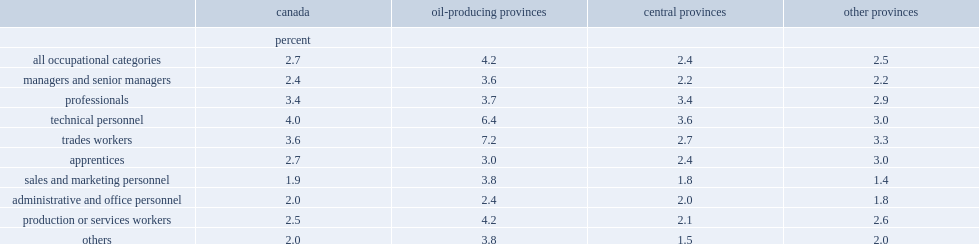List the top3 occupational categories apparently in greatest demand. Technical personnel trades workers professionals. Which province need technical personnel and trades workers most? Oil-producing provinces. Which province need production and services workers and sales personnel most? Oil-producing provinces. 